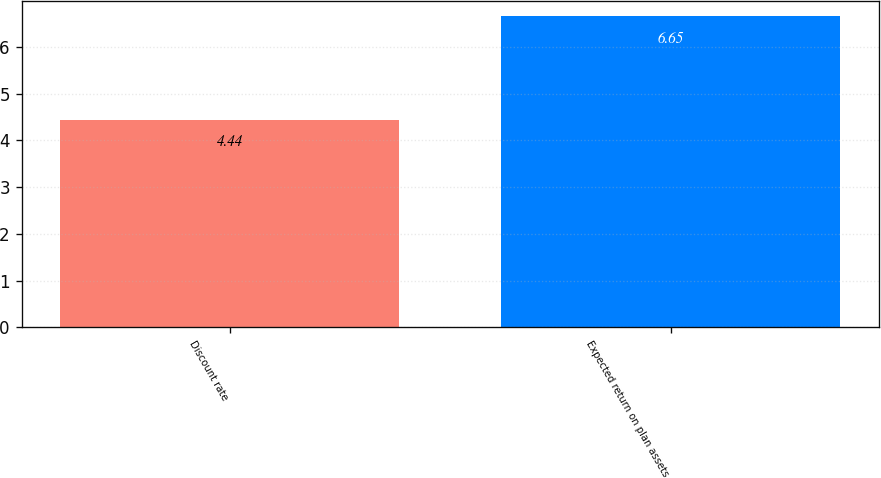Convert chart to OTSL. <chart><loc_0><loc_0><loc_500><loc_500><bar_chart><fcel>Discount rate<fcel>Expected return on plan assets<nl><fcel>4.44<fcel>6.65<nl></chart> 